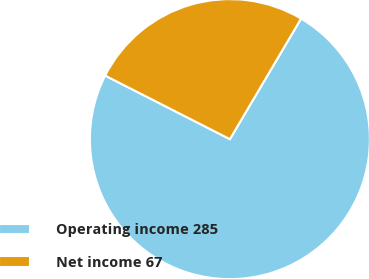Convert chart. <chart><loc_0><loc_0><loc_500><loc_500><pie_chart><fcel>Operating income 285<fcel>Net income 67<nl><fcel>74.01%<fcel>25.99%<nl></chart> 